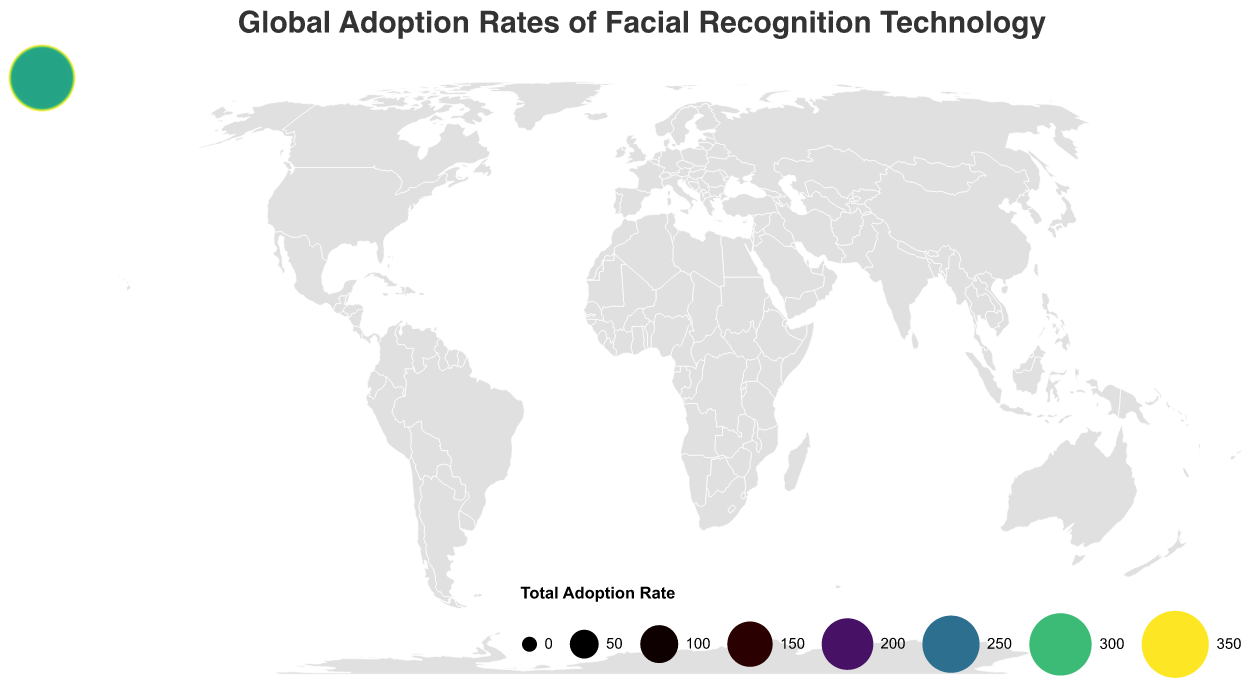What is the title of the figure? The title is displayed at the top of the figure in large font.
Answer: Global Adoption Rates of Facial Recognition Technology Which country has the highest total adoption rate? Look for the largest circle on the map, which represents the highest total adoption rate.
Answer: China Which two countries have the lowest total adoption rates? Identify the two smallest circles on the map, which represent the lowest total adoption rates.
Answer: Brazil and France What is the adoption rate for facial recognition in the Finance industry in Japan? Locate Japan on the map and refer to the tooltip or legend information that shows industry-specific rates.
Answer: 62 How does the adoption rate in the Retail industry compare between Germany and India? Locate Germany and India on the map and compare the sizes of their respective circles for the Retail industry.
Answer: Germany: 33, India: 50 What is the average total adoption rate across all countries? Sum the total adoption rates for all countries and divide by the number of countries.
Answer: (384+428+234+260+211+313+193+328+222+242+204+282+304+294+281)/15 ≈ 280 Which country has a higher adoption rate in Healthcare: Canada or Russia? Find both Canada and Russia on the map and compare their Healthcare adoption rates.
Answer: Russia How many countries have a Government adoption rate of 75% or above? Count the countries with Government adoption rates ≥ 75% by referring to the legend or tooltips.
Answer: 8 (United States, China, India, Russia, South Korea, Singapore, Israel, United Arab Emirates) What is the sum of the adoption rates in the Transportation sector for Australia and South Korea? Add the adoption rates for Transportation in Australia and South Korea.
Answer: 43+58 = 101 Which country has the largest difference between the Finance and Healthcare adoption rates? Calculate (Finance - Healthcare) for each country and identify the largest difference.
Answer: China (80 - 47 = 33) 